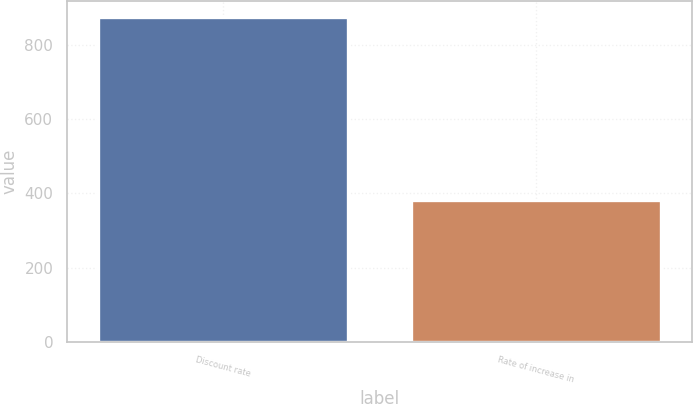Convert chart. <chart><loc_0><loc_0><loc_500><loc_500><bar_chart><fcel>Discount rate<fcel>Rate of increase in<nl><fcel>874<fcel>381<nl></chart> 